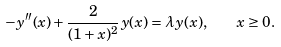Convert formula to latex. <formula><loc_0><loc_0><loc_500><loc_500>- y ^ { \prime \prime } ( x ) + \frac { 2 } { ( 1 + x ) ^ { 2 } } y ( x ) = \lambda y ( x ) , \quad x \geq 0 .</formula> 